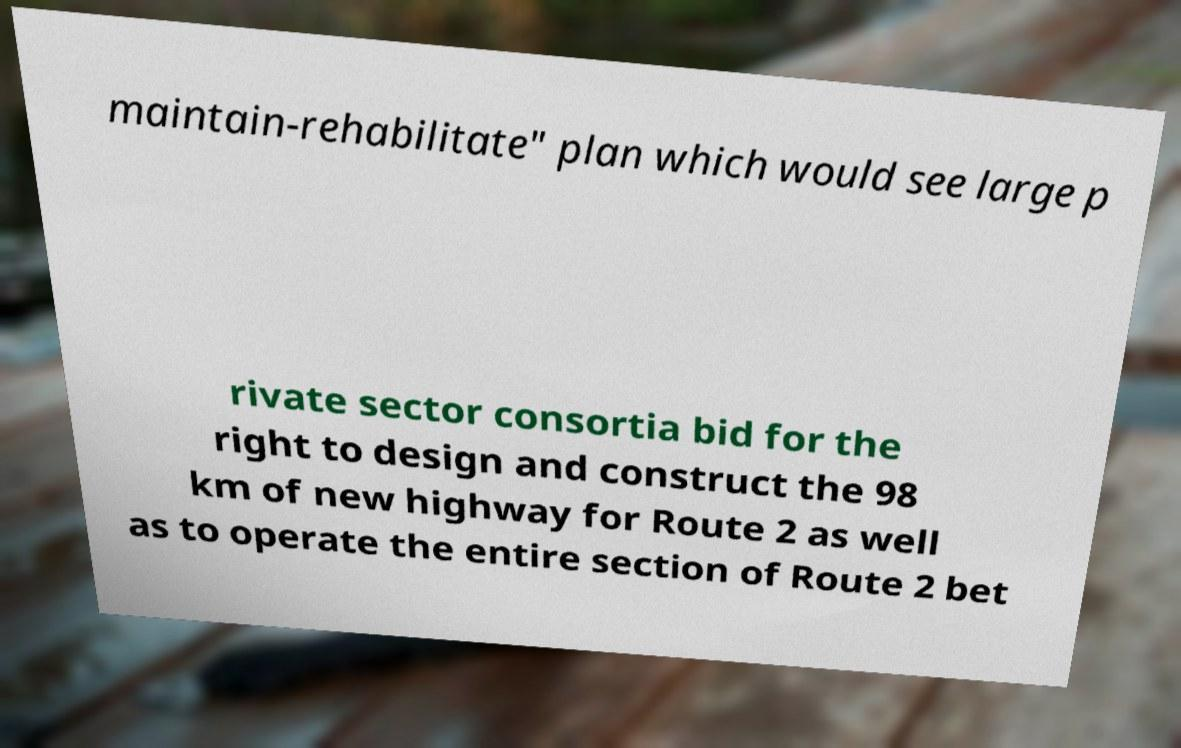Can you accurately transcribe the text from the provided image for me? maintain-rehabilitate" plan which would see large p rivate sector consortia bid for the right to design and construct the 98 km of new highway for Route 2 as well as to operate the entire section of Route 2 bet 